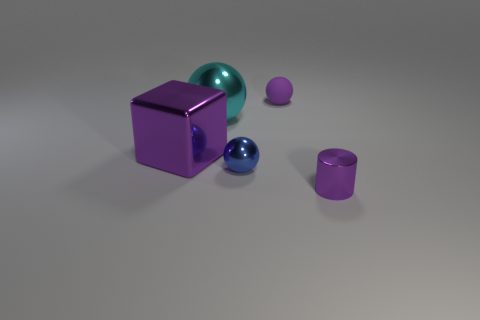Is there any other thing that is the same shape as the tiny purple shiny object?
Your response must be concise. No. Are there any blue shiny spheres to the left of the shiny sphere behind the big metal block?
Make the answer very short. No. How many matte spheres are the same size as the cylinder?
Offer a terse response. 1. What number of tiny blue objects are behind the small rubber sphere that is behind the small thing that is right of the matte thing?
Make the answer very short. 0. How many objects are both behind the purple shiny block and to the right of the blue shiny ball?
Your answer should be compact. 1. Is there anything else that has the same color as the shiny cylinder?
Provide a succinct answer. Yes. What number of matte things are either balls or large purple objects?
Give a very brief answer. 1. What is the small purple thing on the left side of the small metal object in front of the small metal object on the left side of the purple matte object made of?
Ensure brevity in your answer.  Rubber. There is a purple object in front of the purple shiny thing on the left side of the small purple cylinder; what is its material?
Provide a succinct answer. Metal. Is the size of the purple shiny thing left of the matte sphere the same as the purple thing that is in front of the big purple object?
Give a very brief answer. No. 